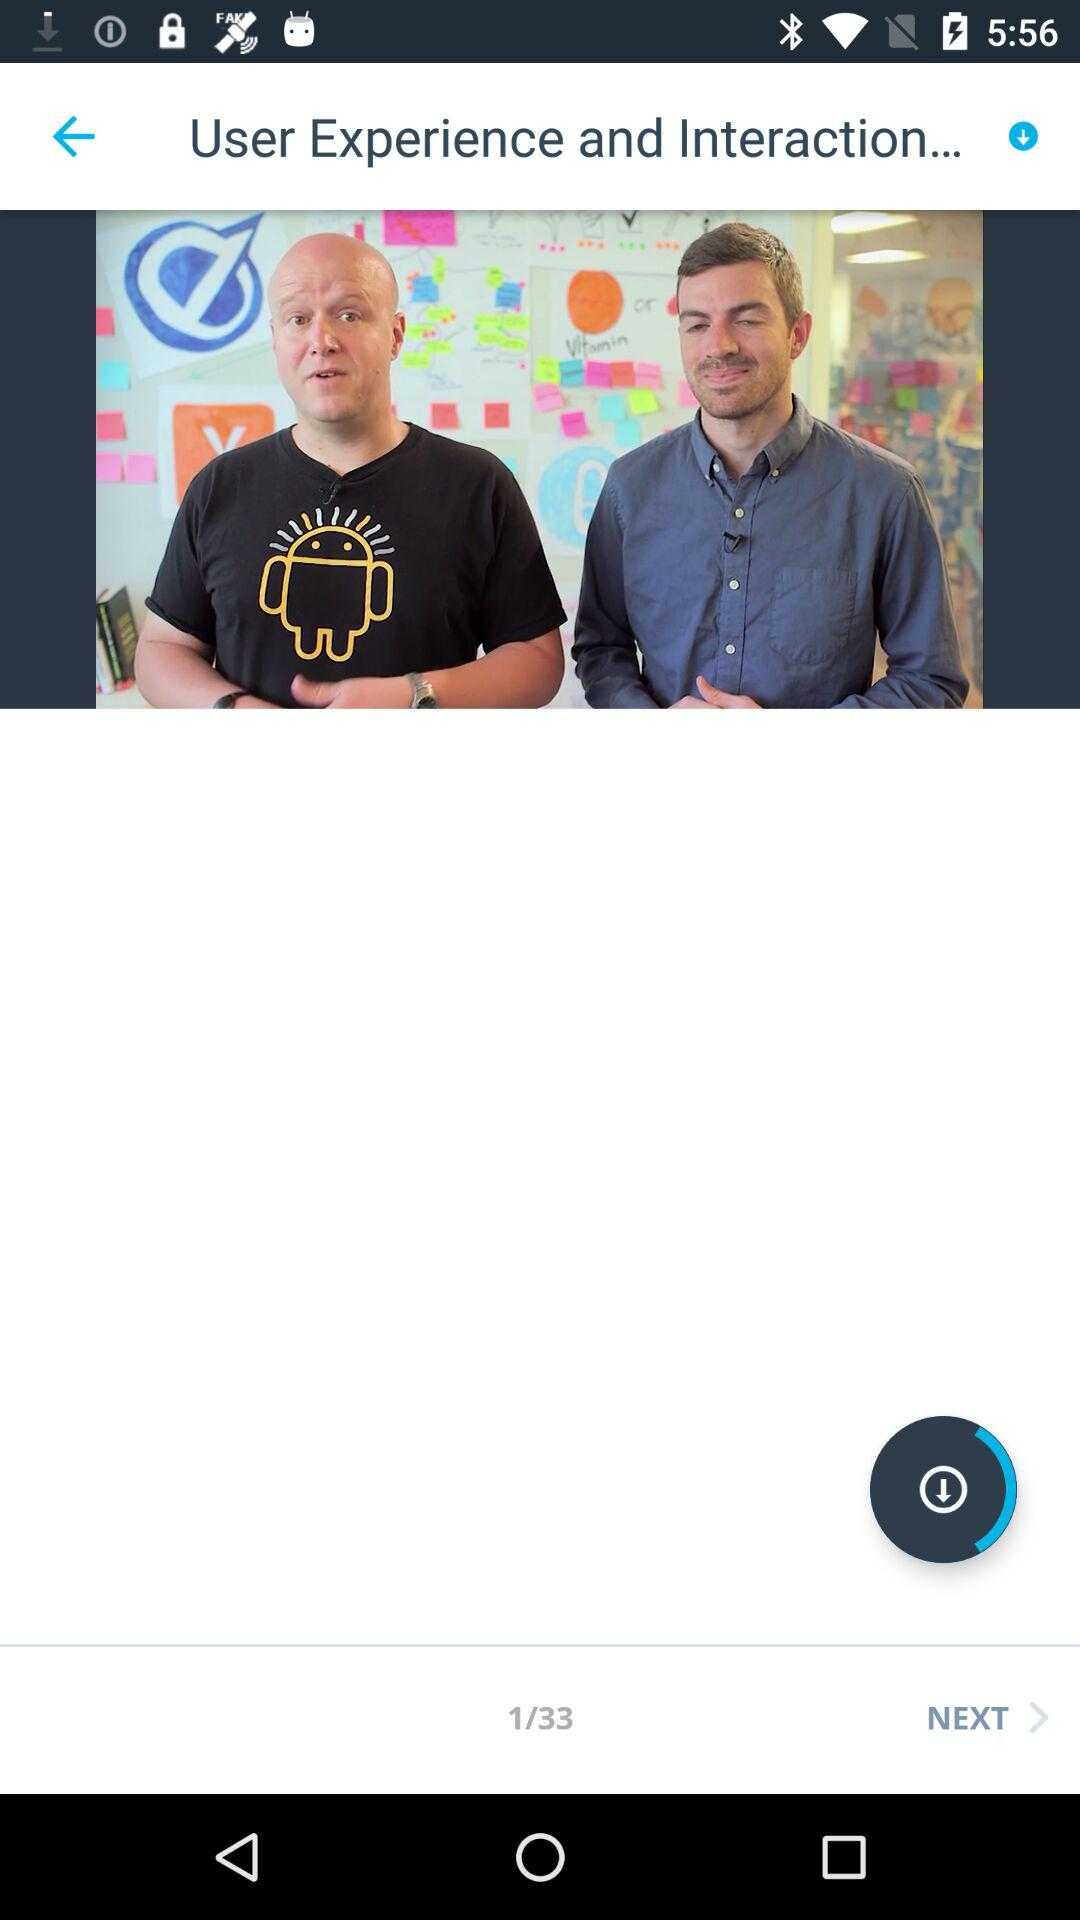What is the total number of slides? The total number of slides is 33. 